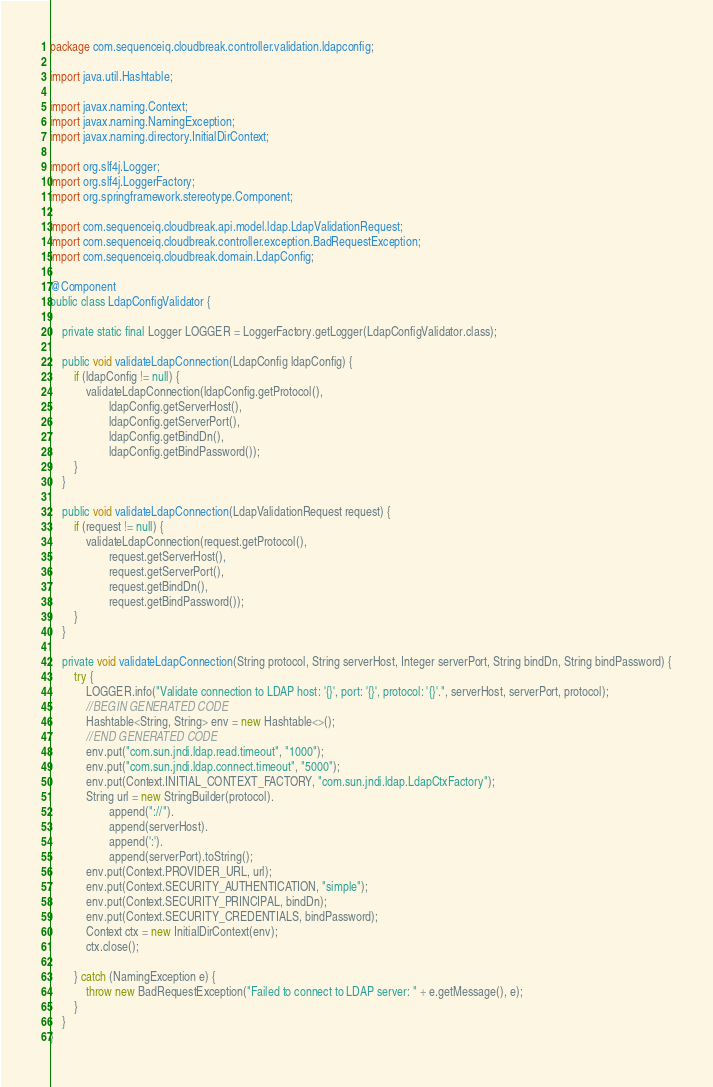Convert code to text. <code><loc_0><loc_0><loc_500><loc_500><_Java_>package com.sequenceiq.cloudbreak.controller.validation.ldapconfig;

import java.util.Hashtable;

import javax.naming.Context;
import javax.naming.NamingException;
import javax.naming.directory.InitialDirContext;

import org.slf4j.Logger;
import org.slf4j.LoggerFactory;
import org.springframework.stereotype.Component;

import com.sequenceiq.cloudbreak.api.model.ldap.LdapValidationRequest;
import com.sequenceiq.cloudbreak.controller.exception.BadRequestException;
import com.sequenceiq.cloudbreak.domain.LdapConfig;

@Component
public class LdapConfigValidator {

    private static final Logger LOGGER = LoggerFactory.getLogger(LdapConfigValidator.class);

    public void validateLdapConnection(LdapConfig ldapConfig) {
        if (ldapConfig != null) {
            validateLdapConnection(ldapConfig.getProtocol(),
                    ldapConfig.getServerHost(),
                    ldapConfig.getServerPort(),
                    ldapConfig.getBindDn(),
                    ldapConfig.getBindPassword());
        }
    }

    public void validateLdapConnection(LdapValidationRequest request) {
        if (request != null) {
            validateLdapConnection(request.getProtocol(),
                    request.getServerHost(),
                    request.getServerPort(),
                    request.getBindDn(),
                    request.getBindPassword());
        }
    }

    private void validateLdapConnection(String protocol, String serverHost, Integer serverPort, String bindDn, String bindPassword) {
        try {
            LOGGER.info("Validate connection to LDAP host: '{}', port: '{}', protocol: '{}'.", serverHost, serverPort, protocol);
            //BEGIN GENERATED CODE
            Hashtable<String, String> env = new Hashtable<>();
            //END GENERATED CODE
            env.put("com.sun.jndi.ldap.read.timeout", "1000");
            env.put("com.sun.jndi.ldap.connect.timeout", "5000");
            env.put(Context.INITIAL_CONTEXT_FACTORY, "com.sun.jndi.ldap.LdapCtxFactory");
            String url = new StringBuilder(protocol).
                    append("://").
                    append(serverHost).
                    append(':').
                    append(serverPort).toString();
            env.put(Context.PROVIDER_URL, url);
            env.put(Context.SECURITY_AUTHENTICATION, "simple");
            env.put(Context.SECURITY_PRINCIPAL, bindDn);
            env.put(Context.SECURITY_CREDENTIALS, bindPassword);
            Context ctx = new InitialDirContext(env);
            ctx.close();

        } catch (NamingException e) {
            throw new BadRequestException("Failed to connect to LDAP server: " + e.getMessage(), e);
        }
    }
}
</code> 